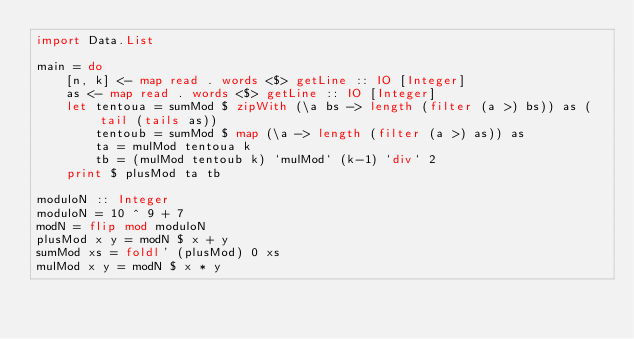<code> <loc_0><loc_0><loc_500><loc_500><_Haskell_>import Data.List

main = do
    [n, k] <- map read . words <$> getLine :: IO [Integer]
    as <- map read . words <$> getLine :: IO [Integer]
    let tentoua = sumMod $ zipWith (\a bs -> length (filter (a >) bs)) as (tail (tails as))
        tentoub = sumMod $ map (\a -> length (filter (a >) as)) as
        ta = mulMod tentoua k
        tb = (mulMod tentoub k) `mulMod` (k-1) `div` 2
    print $ plusMod ta tb

moduloN :: Integer
moduloN = 10 ^ 9 + 7
modN = flip mod moduloN
plusMod x y = modN $ x + y
sumMod xs = foldl' (plusMod) 0 xs
mulMod x y = modN $ x * y</code> 